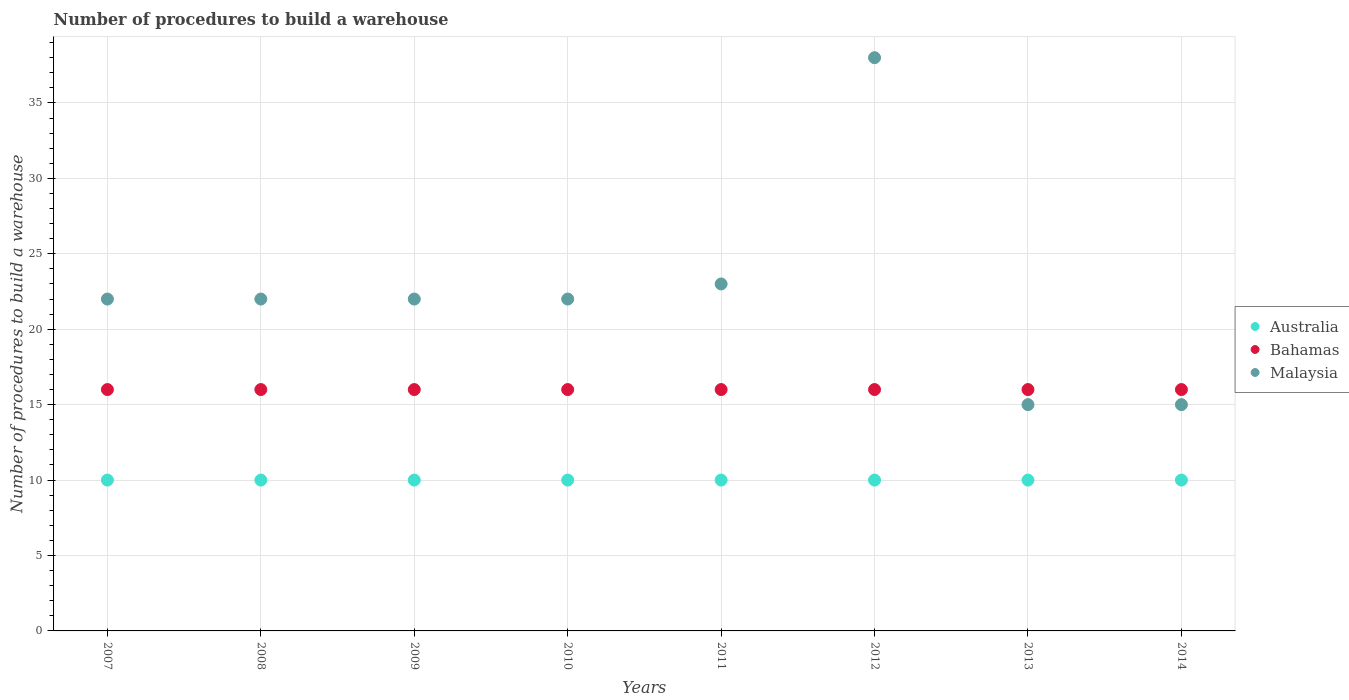How many different coloured dotlines are there?
Give a very brief answer. 3. Is the number of dotlines equal to the number of legend labels?
Provide a succinct answer. Yes. What is the number of procedures to build a warehouse in in Bahamas in 2008?
Provide a short and direct response. 16. Across all years, what is the minimum number of procedures to build a warehouse in in Malaysia?
Ensure brevity in your answer.  15. What is the total number of procedures to build a warehouse in in Bahamas in the graph?
Offer a terse response. 128. What is the difference between the number of procedures to build a warehouse in in Australia in 2010 and that in 2011?
Make the answer very short. 0. What is the difference between the number of procedures to build a warehouse in in Bahamas in 2012 and the number of procedures to build a warehouse in in Australia in 2010?
Your answer should be compact. 6. Is the number of procedures to build a warehouse in in Bahamas in 2013 less than that in 2014?
Offer a very short reply. No. Is the difference between the number of procedures to build a warehouse in in Australia in 2009 and 2011 greater than the difference between the number of procedures to build a warehouse in in Bahamas in 2009 and 2011?
Provide a short and direct response. No. What is the difference between the highest and the lowest number of procedures to build a warehouse in in Bahamas?
Keep it short and to the point. 0. In how many years, is the number of procedures to build a warehouse in in Bahamas greater than the average number of procedures to build a warehouse in in Bahamas taken over all years?
Keep it short and to the point. 0. Is it the case that in every year, the sum of the number of procedures to build a warehouse in in Australia and number of procedures to build a warehouse in in Malaysia  is greater than the number of procedures to build a warehouse in in Bahamas?
Your answer should be very brief. Yes. Is the number of procedures to build a warehouse in in Bahamas strictly less than the number of procedures to build a warehouse in in Malaysia over the years?
Your answer should be very brief. No. How many dotlines are there?
Ensure brevity in your answer.  3. How many years are there in the graph?
Ensure brevity in your answer.  8. Does the graph contain grids?
Provide a succinct answer. Yes. Where does the legend appear in the graph?
Offer a very short reply. Center right. What is the title of the graph?
Ensure brevity in your answer.  Number of procedures to build a warehouse. What is the label or title of the X-axis?
Provide a short and direct response. Years. What is the label or title of the Y-axis?
Ensure brevity in your answer.  Number of procedures to build a warehouse. What is the Number of procedures to build a warehouse in Australia in 2007?
Keep it short and to the point. 10. What is the Number of procedures to build a warehouse of Bahamas in 2007?
Your response must be concise. 16. What is the Number of procedures to build a warehouse in Malaysia in 2007?
Your response must be concise. 22. What is the Number of procedures to build a warehouse of Bahamas in 2008?
Provide a succinct answer. 16. What is the Number of procedures to build a warehouse in Bahamas in 2009?
Make the answer very short. 16. What is the Number of procedures to build a warehouse of Malaysia in 2009?
Provide a short and direct response. 22. What is the Number of procedures to build a warehouse of Australia in 2010?
Provide a short and direct response. 10. What is the Number of procedures to build a warehouse of Bahamas in 2011?
Make the answer very short. 16. What is the Number of procedures to build a warehouse of Australia in 2012?
Keep it short and to the point. 10. What is the Number of procedures to build a warehouse in Bahamas in 2012?
Offer a terse response. 16. What is the Number of procedures to build a warehouse of Malaysia in 2012?
Make the answer very short. 38. What is the Number of procedures to build a warehouse in Australia in 2014?
Your answer should be compact. 10. What is the Number of procedures to build a warehouse in Malaysia in 2014?
Offer a very short reply. 15. Across all years, what is the maximum Number of procedures to build a warehouse of Australia?
Provide a short and direct response. 10. Across all years, what is the maximum Number of procedures to build a warehouse of Bahamas?
Your answer should be compact. 16. Across all years, what is the minimum Number of procedures to build a warehouse in Australia?
Your answer should be very brief. 10. Across all years, what is the minimum Number of procedures to build a warehouse in Malaysia?
Your answer should be compact. 15. What is the total Number of procedures to build a warehouse of Australia in the graph?
Ensure brevity in your answer.  80. What is the total Number of procedures to build a warehouse of Bahamas in the graph?
Your answer should be very brief. 128. What is the total Number of procedures to build a warehouse of Malaysia in the graph?
Offer a very short reply. 179. What is the difference between the Number of procedures to build a warehouse in Australia in 2007 and that in 2008?
Make the answer very short. 0. What is the difference between the Number of procedures to build a warehouse of Bahamas in 2007 and that in 2008?
Offer a very short reply. 0. What is the difference between the Number of procedures to build a warehouse of Malaysia in 2007 and that in 2010?
Provide a short and direct response. 0. What is the difference between the Number of procedures to build a warehouse in Malaysia in 2007 and that in 2011?
Your answer should be compact. -1. What is the difference between the Number of procedures to build a warehouse of Australia in 2007 and that in 2012?
Keep it short and to the point. 0. What is the difference between the Number of procedures to build a warehouse in Malaysia in 2007 and that in 2014?
Give a very brief answer. 7. What is the difference between the Number of procedures to build a warehouse of Australia in 2008 and that in 2009?
Offer a very short reply. 0. What is the difference between the Number of procedures to build a warehouse in Bahamas in 2008 and that in 2010?
Provide a short and direct response. 0. What is the difference between the Number of procedures to build a warehouse in Malaysia in 2008 and that in 2010?
Provide a succinct answer. 0. What is the difference between the Number of procedures to build a warehouse in Australia in 2008 and that in 2012?
Give a very brief answer. 0. What is the difference between the Number of procedures to build a warehouse of Bahamas in 2008 and that in 2012?
Your response must be concise. 0. What is the difference between the Number of procedures to build a warehouse in Malaysia in 2008 and that in 2012?
Give a very brief answer. -16. What is the difference between the Number of procedures to build a warehouse in Bahamas in 2008 and that in 2013?
Your answer should be compact. 0. What is the difference between the Number of procedures to build a warehouse in Malaysia in 2008 and that in 2013?
Ensure brevity in your answer.  7. What is the difference between the Number of procedures to build a warehouse in Australia in 2008 and that in 2014?
Ensure brevity in your answer.  0. What is the difference between the Number of procedures to build a warehouse of Malaysia in 2008 and that in 2014?
Offer a terse response. 7. What is the difference between the Number of procedures to build a warehouse of Australia in 2009 and that in 2010?
Make the answer very short. 0. What is the difference between the Number of procedures to build a warehouse in Malaysia in 2009 and that in 2011?
Your response must be concise. -1. What is the difference between the Number of procedures to build a warehouse of Malaysia in 2009 and that in 2012?
Offer a very short reply. -16. What is the difference between the Number of procedures to build a warehouse of Australia in 2009 and that in 2013?
Make the answer very short. 0. What is the difference between the Number of procedures to build a warehouse of Malaysia in 2009 and that in 2013?
Your answer should be compact. 7. What is the difference between the Number of procedures to build a warehouse in Bahamas in 2009 and that in 2014?
Your response must be concise. 0. What is the difference between the Number of procedures to build a warehouse in Malaysia in 2009 and that in 2014?
Provide a succinct answer. 7. What is the difference between the Number of procedures to build a warehouse of Australia in 2010 and that in 2012?
Provide a short and direct response. 0. What is the difference between the Number of procedures to build a warehouse in Bahamas in 2010 and that in 2013?
Your answer should be very brief. 0. What is the difference between the Number of procedures to build a warehouse in Australia in 2010 and that in 2014?
Give a very brief answer. 0. What is the difference between the Number of procedures to build a warehouse in Malaysia in 2010 and that in 2014?
Offer a terse response. 7. What is the difference between the Number of procedures to build a warehouse of Bahamas in 2011 and that in 2012?
Ensure brevity in your answer.  0. What is the difference between the Number of procedures to build a warehouse of Bahamas in 2011 and that in 2013?
Make the answer very short. 0. What is the difference between the Number of procedures to build a warehouse of Malaysia in 2011 and that in 2013?
Provide a short and direct response. 8. What is the difference between the Number of procedures to build a warehouse of Bahamas in 2011 and that in 2014?
Provide a short and direct response. 0. What is the difference between the Number of procedures to build a warehouse in Malaysia in 2011 and that in 2014?
Provide a succinct answer. 8. What is the difference between the Number of procedures to build a warehouse of Australia in 2012 and that in 2013?
Keep it short and to the point. 0. What is the difference between the Number of procedures to build a warehouse in Bahamas in 2012 and that in 2013?
Provide a succinct answer. 0. What is the difference between the Number of procedures to build a warehouse of Malaysia in 2012 and that in 2013?
Your answer should be compact. 23. What is the difference between the Number of procedures to build a warehouse in Bahamas in 2012 and that in 2014?
Your response must be concise. 0. What is the difference between the Number of procedures to build a warehouse in Malaysia in 2012 and that in 2014?
Provide a succinct answer. 23. What is the difference between the Number of procedures to build a warehouse in Bahamas in 2013 and that in 2014?
Provide a succinct answer. 0. What is the difference between the Number of procedures to build a warehouse in Australia in 2007 and the Number of procedures to build a warehouse in Malaysia in 2008?
Make the answer very short. -12. What is the difference between the Number of procedures to build a warehouse in Bahamas in 2007 and the Number of procedures to build a warehouse in Malaysia in 2008?
Keep it short and to the point. -6. What is the difference between the Number of procedures to build a warehouse of Australia in 2007 and the Number of procedures to build a warehouse of Bahamas in 2010?
Offer a very short reply. -6. What is the difference between the Number of procedures to build a warehouse of Australia in 2007 and the Number of procedures to build a warehouse of Malaysia in 2010?
Make the answer very short. -12. What is the difference between the Number of procedures to build a warehouse of Australia in 2007 and the Number of procedures to build a warehouse of Bahamas in 2011?
Provide a succinct answer. -6. What is the difference between the Number of procedures to build a warehouse in Australia in 2007 and the Number of procedures to build a warehouse in Malaysia in 2011?
Give a very brief answer. -13. What is the difference between the Number of procedures to build a warehouse in Bahamas in 2007 and the Number of procedures to build a warehouse in Malaysia in 2012?
Your answer should be very brief. -22. What is the difference between the Number of procedures to build a warehouse in Australia in 2007 and the Number of procedures to build a warehouse in Malaysia in 2013?
Provide a succinct answer. -5. What is the difference between the Number of procedures to build a warehouse in Australia in 2007 and the Number of procedures to build a warehouse in Bahamas in 2014?
Provide a short and direct response. -6. What is the difference between the Number of procedures to build a warehouse in Australia in 2007 and the Number of procedures to build a warehouse in Malaysia in 2014?
Make the answer very short. -5. What is the difference between the Number of procedures to build a warehouse of Australia in 2008 and the Number of procedures to build a warehouse of Malaysia in 2009?
Give a very brief answer. -12. What is the difference between the Number of procedures to build a warehouse of Bahamas in 2008 and the Number of procedures to build a warehouse of Malaysia in 2009?
Your answer should be very brief. -6. What is the difference between the Number of procedures to build a warehouse in Australia in 2008 and the Number of procedures to build a warehouse in Malaysia in 2010?
Provide a short and direct response. -12. What is the difference between the Number of procedures to build a warehouse of Bahamas in 2008 and the Number of procedures to build a warehouse of Malaysia in 2010?
Ensure brevity in your answer.  -6. What is the difference between the Number of procedures to build a warehouse of Australia in 2008 and the Number of procedures to build a warehouse of Malaysia in 2011?
Provide a succinct answer. -13. What is the difference between the Number of procedures to build a warehouse of Bahamas in 2008 and the Number of procedures to build a warehouse of Malaysia in 2011?
Your answer should be very brief. -7. What is the difference between the Number of procedures to build a warehouse in Australia in 2008 and the Number of procedures to build a warehouse in Bahamas in 2012?
Make the answer very short. -6. What is the difference between the Number of procedures to build a warehouse of Australia in 2008 and the Number of procedures to build a warehouse of Malaysia in 2012?
Offer a very short reply. -28. What is the difference between the Number of procedures to build a warehouse of Australia in 2008 and the Number of procedures to build a warehouse of Bahamas in 2013?
Offer a terse response. -6. What is the difference between the Number of procedures to build a warehouse of Bahamas in 2008 and the Number of procedures to build a warehouse of Malaysia in 2013?
Offer a very short reply. 1. What is the difference between the Number of procedures to build a warehouse in Australia in 2008 and the Number of procedures to build a warehouse in Bahamas in 2014?
Give a very brief answer. -6. What is the difference between the Number of procedures to build a warehouse in Australia in 2008 and the Number of procedures to build a warehouse in Malaysia in 2014?
Offer a terse response. -5. What is the difference between the Number of procedures to build a warehouse of Australia in 2009 and the Number of procedures to build a warehouse of Bahamas in 2010?
Offer a very short reply. -6. What is the difference between the Number of procedures to build a warehouse of Australia in 2009 and the Number of procedures to build a warehouse of Malaysia in 2010?
Your response must be concise. -12. What is the difference between the Number of procedures to build a warehouse of Bahamas in 2009 and the Number of procedures to build a warehouse of Malaysia in 2010?
Your response must be concise. -6. What is the difference between the Number of procedures to build a warehouse of Australia in 2009 and the Number of procedures to build a warehouse of Bahamas in 2012?
Offer a terse response. -6. What is the difference between the Number of procedures to build a warehouse in Bahamas in 2009 and the Number of procedures to build a warehouse in Malaysia in 2012?
Provide a short and direct response. -22. What is the difference between the Number of procedures to build a warehouse in Australia in 2009 and the Number of procedures to build a warehouse in Malaysia in 2013?
Make the answer very short. -5. What is the difference between the Number of procedures to build a warehouse of Australia in 2009 and the Number of procedures to build a warehouse of Bahamas in 2014?
Your answer should be very brief. -6. What is the difference between the Number of procedures to build a warehouse in Australia in 2009 and the Number of procedures to build a warehouse in Malaysia in 2014?
Give a very brief answer. -5. What is the difference between the Number of procedures to build a warehouse of Bahamas in 2009 and the Number of procedures to build a warehouse of Malaysia in 2014?
Your response must be concise. 1. What is the difference between the Number of procedures to build a warehouse of Australia in 2010 and the Number of procedures to build a warehouse of Malaysia in 2011?
Your response must be concise. -13. What is the difference between the Number of procedures to build a warehouse in Bahamas in 2010 and the Number of procedures to build a warehouse in Malaysia in 2011?
Keep it short and to the point. -7. What is the difference between the Number of procedures to build a warehouse in Australia in 2010 and the Number of procedures to build a warehouse in Bahamas in 2012?
Give a very brief answer. -6. What is the difference between the Number of procedures to build a warehouse in Australia in 2010 and the Number of procedures to build a warehouse in Malaysia in 2012?
Keep it short and to the point. -28. What is the difference between the Number of procedures to build a warehouse in Australia in 2010 and the Number of procedures to build a warehouse in Bahamas in 2013?
Ensure brevity in your answer.  -6. What is the difference between the Number of procedures to build a warehouse in Australia in 2010 and the Number of procedures to build a warehouse in Bahamas in 2014?
Your answer should be compact. -6. What is the difference between the Number of procedures to build a warehouse in Australia in 2010 and the Number of procedures to build a warehouse in Malaysia in 2014?
Provide a succinct answer. -5. What is the difference between the Number of procedures to build a warehouse of Bahamas in 2010 and the Number of procedures to build a warehouse of Malaysia in 2014?
Provide a succinct answer. 1. What is the difference between the Number of procedures to build a warehouse of Australia in 2011 and the Number of procedures to build a warehouse of Malaysia in 2012?
Offer a very short reply. -28. What is the difference between the Number of procedures to build a warehouse of Australia in 2011 and the Number of procedures to build a warehouse of Bahamas in 2013?
Ensure brevity in your answer.  -6. What is the difference between the Number of procedures to build a warehouse of Australia in 2011 and the Number of procedures to build a warehouse of Bahamas in 2014?
Offer a terse response. -6. What is the difference between the Number of procedures to build a warehouse in Bahamas in 2011 and the Number of procedures to build a warehouse in Malaysia in 2014?
Give a very brief answer. 1. What is the difference between the Number of procedures to build a warehouse of Australia in 2012 and the Number of procedures to build a warehouse of Bahamas in 2013?
Keep it short and to the point. -6. What is the difference between the Number of procedures to build a warehouse of Australia in 2012 and the Number of procedures to build a warehouse of Bahamas in 2014?
Your response must be concise. -6. What is the difference between the Number of procedures to build a warehouse in Australia in 2012 and the Number of procedures to build a warehouse in Malaysia in 2014?
Offer a very short reply. -5. What is the difference between the Number of procedures to build a warehouse of Bahamas in 2012 and the Number of procedures to build a warehouse of Malaysia in 2014?
Keep it short and to the point. 1. What is the difference between the Number of procedures to build a warehouse in Australia in 2013 and the Number of procedures to build a warehouse in Bahamas in 2014?
Provide a short and direct response. -6. What is the average Number of procedures to build a warehouse in Australia per year?
Your answer should be compact. 10. What is the average Number of procedures to build a warehouse of Malaysia per year?
Offer a very short reply. 22.38. In the year 2007, what is the difference between the Number of procedures to build a warehouse of Australia and Number of procedures to build a warehouse of Bahamas?
Give a very brief answer. -6. In the year 2007, what is the difference between the Number of procedures to build a warehouse of Australia and Number of procedures to build a warehouse of Malaysia?
Your answer should be compact. -12. In the year 2007, what is the difference between the Number of procedures to build a warehouse in Bahamas and Number of procedures to build a warehouse in Malaysia?
Your answer should be very brief. -6. In the year 2009, what is the difference between the Number of procedures to build a warehouse in Australia and Number of procedures to build a warehouse in Malaysia?
Keep it short and to the point. -12. In the year 2009, what is the difference between the Number of procedures to build a warehouse of Bahamas and Number of procedures to build a warehouse of Malaysia?
Provide a succinct answer. -6. In the year 2010, what is the difference between the Number of procedures to build a warehouse of Australia and Number of procedures to build a warehouse of Bahamas?
Ensure brevity in your answer.  -6. In the year 2011, what is the difference between the Number of procedures to build a warehouse in Australia and Number of procedures to build a warehouse in Bahamas?
Provide a succinct answer. -6. In the year 2011, what is the difference between the Number of procedures to build a warehouse of Australia and Number of procedures to build a warehouse of Malaysia?
Your response must be concise. -13. In the year 2012, what is the difference between the Number of procedures to build a warehouse of Australia and Number of procedures to build a warehouse of Bahamas?
Provide a succinct answer. -6. In the year 2012, what is the difference between the Number of procedures to build a warehouse in Australia and Number of procedures to build a warehouse in Malaysia?
Your answer should be compact. -28. In the year 2013, what is the difference between the Number of procedures to build a warehouse of Bahamas and Number of procedures to build a warehouse of Malaysia?
Your response must be concise. 1. In the year 2014, what is the difference between the Number of procedures to build a warehouse of Australia and Number of procedures to build a warehouse of Malaysia?
Offer a terse response. -5. In the year 2014, what is the difference between the Number of procedures to build a warehouse in Bahamas and Number of procedures to build a warehouse in Malaysia?
Ensure brevity in your answer.  1. What is the ratio of the Number of procedures to build a warehouse of Australia in 2007 to that in 2008?
Provide a short and direct response. 1. What is the ratio of the Number of procedures to build a warehouse in Malaysia in 2007 to that in 2008?
Offer a terse response. 1. What is the ratio of the Number of procedures to build a warehouse in Bahamas in 2007 to that in 2009?
Offer a very short reply. 1. What is the ratio of the Number of procedures to build a warehouse in Malaysia in 2007 to that in 2009?
Make the answer very short. 1. What is the ratio of the Number of procedures to build a warehouse in Australia in 2007 to that in 2010?
Your response must be concise. 1. What is the ratio of the Number of procedures to build a warehouse of Bahamas in 2007 to that in 2011?
Provide a short and direct response. 1. What is the ratio of the Number of procedures to build a warehouse of Malaysia in 2007 to that in 2011?
Your answer should be very brief. 0.96. What is the ratio of the Number of procedures to build a warehouse in Malaysia in 2007 to that in 2012?
Your response must be concise. 0.58. What is the ratio of the Number of procedures to build a warehouse in Malaysia in 2007 to that in 2013?
Offer a terse response. 1.47. What is the ratio of the Number of procedures to build a warehouse of Australia in 2007 to that in 2014?
Provide a short and direct response. 1. What is the ratio of the Number of procedures to build a warehouse of Bahamas in 2007 to that in 2014?
Provide a succinct answer. 1. What is the ratio of the Number of procedures to build a warehouse in Malaysia in 2007 to that in 2014?
Provide a succinct answer. 1.47. What is the ratio of the Number of procedures to build a warehouse in Malaysia in 2008 to that in 2009?
Provide a short and direct response. 1. What is the ratio of the Number of procedures to build a warehouse of Bahamas in 2008 to that in 2010?
Offer a terse response. 1. What is the ratio of the Number of procedures to build a warehouse of Malaysia in 2008 to that in 2010?
Ensure brevity in your answer.  1. What is the ratio of the Number of procedures to build a warehouse in Australia in 2008 to that in 2011?
Ensure brevity in your answer.  1. What is the ratio of the Number of procedures to build a warehouse of Malaysia in 2008 to that in 2011?
Your answer should be compact. 0.96. What is the ratio of the Number of procedures to build a warehouse of Australia in 2008 to that in 2012?
Provide a short and direct response. 1. What is the ratio of the Number of procedures to build a warehouse of Malaysia in 2008 to that in 2012?
Your answer should be very brief. 0.58. What is the ratio of the Number of procedures to build a warehouse in Bahamas in 2008 to that in 2013?
Provide a succinct answer. 1. What is the ratio of the Number of procedures to build a warehouse of Malaysia in 2008 to that in 2013?
Make the answer very short. 1.47. What is the ratio of the Number of procedures to build a warehouse in Australia in 2008 to that in 2014?
Provide a short and direct response. 1. What is the ratio of the Number of procedures to build a warehouse in Malaysia in 2008 to that in 2014?
Provide a short and direct response. 1.47. What is the ratio of the Number of procedures to build a warehouse of Australia in 2009 to that in 2010?
Give a very brief answer. 1. What is the ratio of the Number of procedures to build a warehouse in Bahamas in 2009 to that in 2010?
Provide a short and direct response. 1. What is the ratio of the Number of procedures to build a warehouse in Malaysia in 2009 to that in 2010?
Your answer should be compact. 1. What is the ratio of the Number of procedures to build a warehouse in Australia in 2009 to that in 2011?
Your answer should be compact. 1. What is the ratio of the Number of procedures to build a warehouse in Bahamas in 2009 to that in 2011?
Provide a succinct answer. 1. What is the ratio of the Number of procedures to build a warehouse of Malaysia in 2009 to that in 2011?
Provide a succinct answer. 0.96. What is the ratio of the Number of procedures to build a warehouse in Australia in 2009 to that in 2012?
Offer a very short reply. 1. What is the ratio of the Number of procedures to build a warehouse in Malaysia in 2009 to that in 2012?
Keep it short and to the point. 0.58. What is the ratio of the Number of procedures to build a warehouse of Bahamas in 2009 to that in 2013?
Provide a short and direct response. 1. What is the ratio of the Number of procedures to build a warehouse in Malaysia in 2009 to that in 2013?
Provide a succinct answer. 1.47. What is the ratio of the Number of procedures to build a warehouse in Australia in 2009 to that in 2014?
Make the answer very short. 1. What is the ratio of the Number of procedures to build a warehouse in Malaysia in 2009 to that in 2014?
Keep it short and to the point. 1.47. What is the ratio of the Number of procedures to build a warehouse in Australia in 2010 to that in 2011?
Provide a short and direct response. 1. What is the ratio of the Number of procedures to build a warehouse in Malaysia in 2010 to that in 2011?
Make the answer very short. 0.96. What is the ratio of the Number of procedures to build a warehouse in Australia in 2010 to that in 2012?
Your answer should be compact. 1. What is the ratio of the Number of procedures to build a warehouse of Bahamas in 2010 to that in 2012?
Keep it short and to the point. 1. What is the ratio of the Number of procedures to build a warehouse in Malaysia in 2010 to that in 2012?
Keep it short and to the point. 0.58. What is the ratio of the Number of procedures to build a warehouse in Australia in 2010 to that in 2013?
Your answer should be very brief. 1. What is the ratio of the Number of procedures to build a warehouse in Bahamas in 2010 to that in 2013?
Keep it short and to the point. 1. What is the ratio of the Number of procedures to build a warehouse of Malaysia in 2010 to that in 2013?
Ensure brevity in your answer.  1.47. What is the ratio of the Number of procedures to build a warehouse in Bahamas in 2010 to that in 2014?
Provide a succinct answer. 1. What is the ratio of the Number of procedures to build a warehouse in Malaysia in 2010 to that in 2014?
Keep it short and to the point. 1.47. What is the ratio of the Number of procedures to build a warehouse in Australia in 2011 to that in 2012?
Provide a succinct answer. 1. What is the ratio of the Number of procedures to build a warehouse of Malaysia in 2011 to that in 2012?
Ensure brevity in your answer.  0.61. What is the ratio of the Number of procedures to build a warehouse of Bahamas in 2011 to that in 2013?
Your answer should be very brief. 1. What is the ratio of the Number of procedures to build a warehouse of Malaysia in 2011 to that in 2013?
Give a very brief answer. 1.53. What is the ratio of the Number of procedures to build a warehouse in Australia in 2011 to that in 2014?
Your response must be concise. 1. What is the ratio of the Number of procedures to build a warehouse in Malaysia in 2011 to that in 2014?
Provide a short and direct response. 1.53. What is the ratio of the Number of procedures to build a warehouse of Bahamas in 2012 to that in 2013?
Keep it short and to the point. 1. What is the ratio of the Number of procedures to build a warehouse in Malaysia in 2012 to that in 2013?
Provide a succinct answer. 2.53. What is the ratio of the Number of procedures to build a warehouse of Malaysia in 2012 to that in 2014?
Your answer should be compact. 2.53. What is the difference between the highest and the second highest Number of procedures to build a warehouse in Australia?
Provide a short and direct response. 0. What is the difference between the highest and the second highest Number of procedures to build a warehouse of Bahamas?
Make the answer very short. 0. What is the difference between the highest and the lowest Number of procedures to build a warehouse in Australia?
Keep it short and to the point. 0. What is the difference between the highest and the lowest Number of procedures to build a warehouse of Bahamas?
Make the answer very short. 0. 